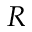Convert formula to latex. <formula><loc_0><loc_0><loc_500><loc_500>R</formula> 